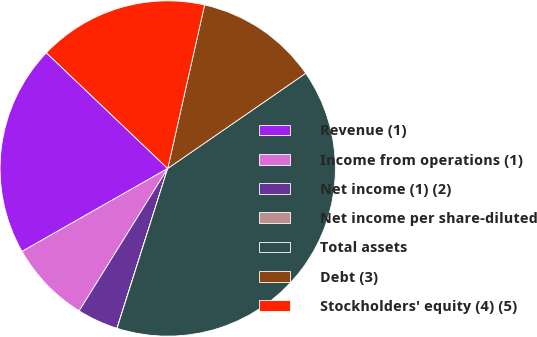Convert chart. <chart><loc_0><loc_0><loc_500><loc_500><pie_chart><fcel>Revenue (1)<fcel>Income from operations (1)<fcel>Net income (1) (2)<fcel>Net income per share-diluted<fcel>Total assets<fcel>Debt (3)<fcel>Stockholders' equity (4) (5)<nl><fcel>20.36%<fcel>7.91%<fcel>3.96%<fcel>0.01%<fcel>39.5%<fcel>11.86%<fcel>16.41%<nl></chart> 